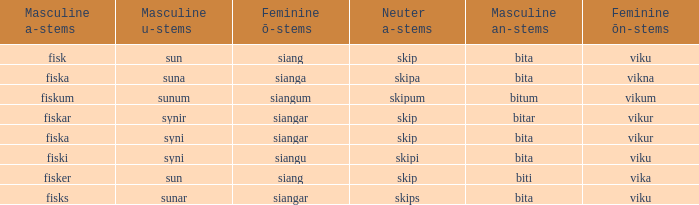What is the u form of the word with a neuter form of skip and a masculine a-ending of fisker? Sun. 